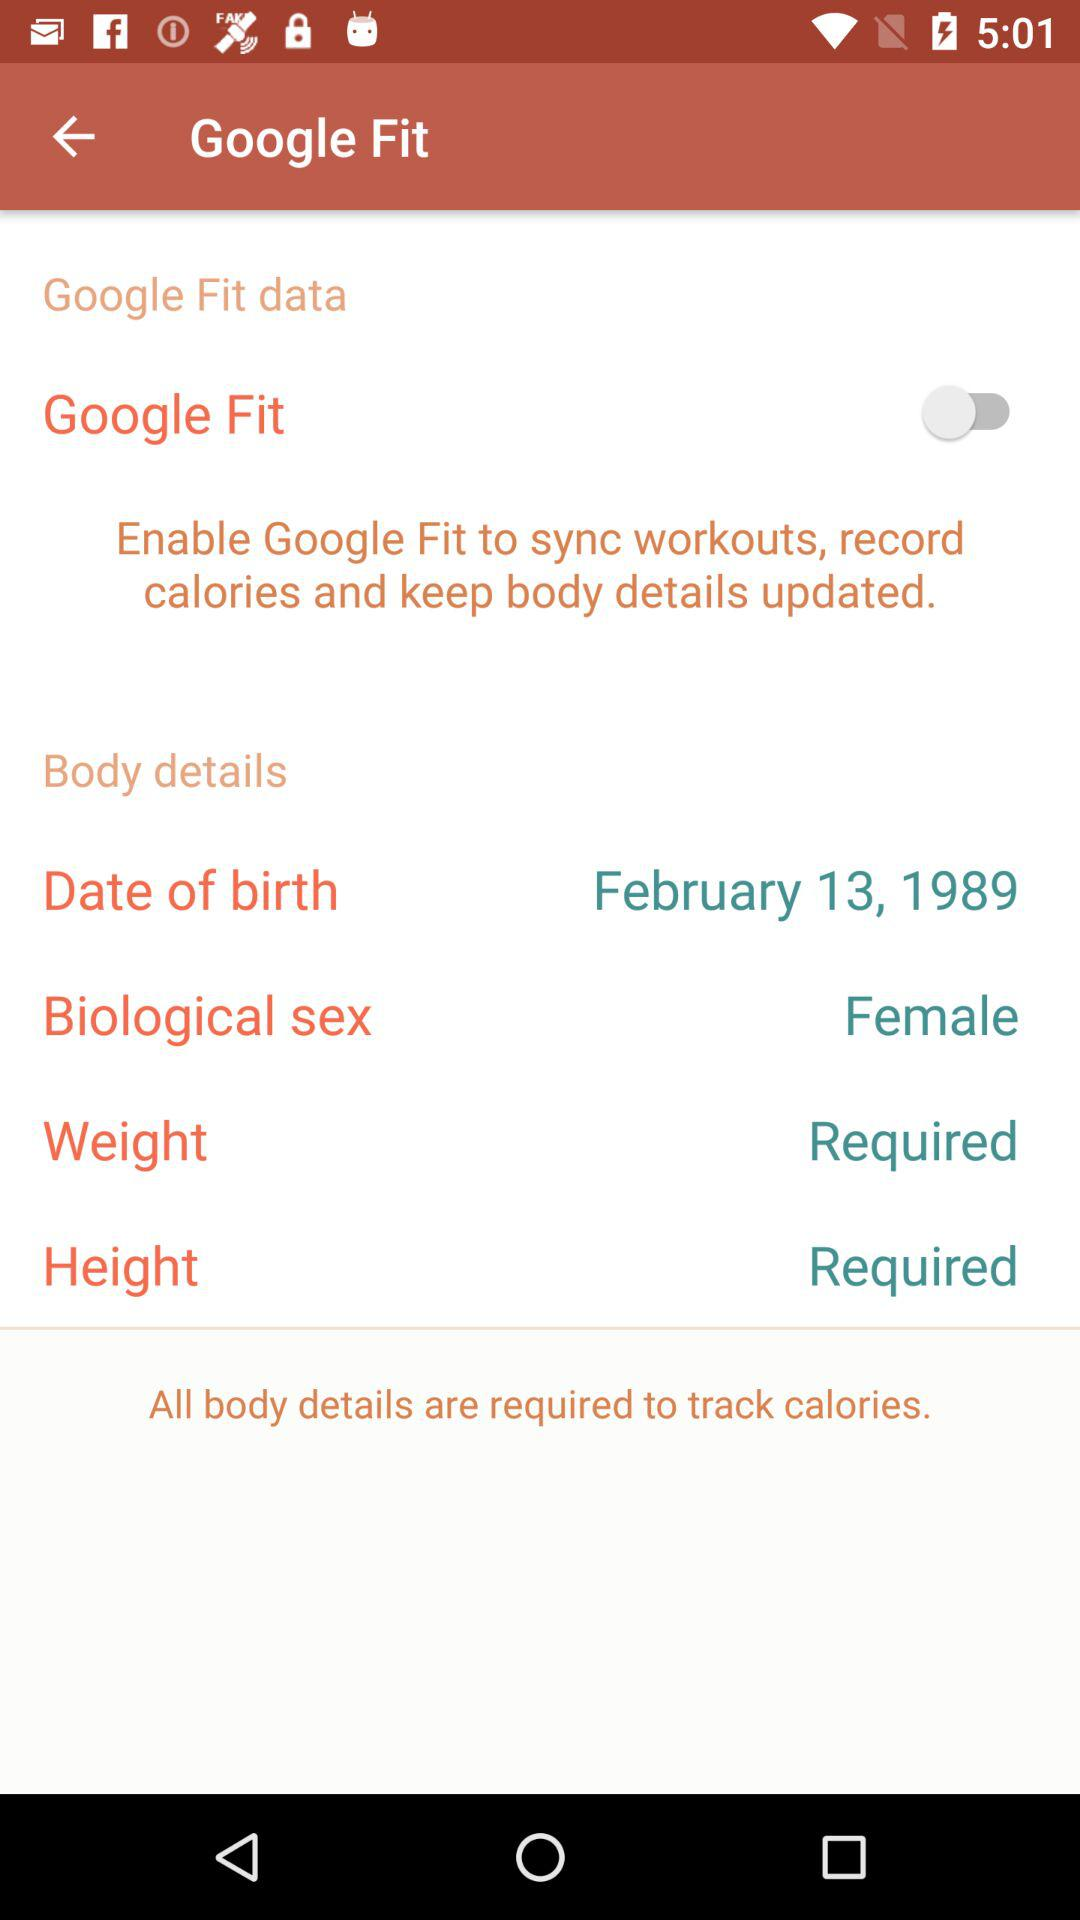What is the date of birth? The date of birth is February 13, 1989. 